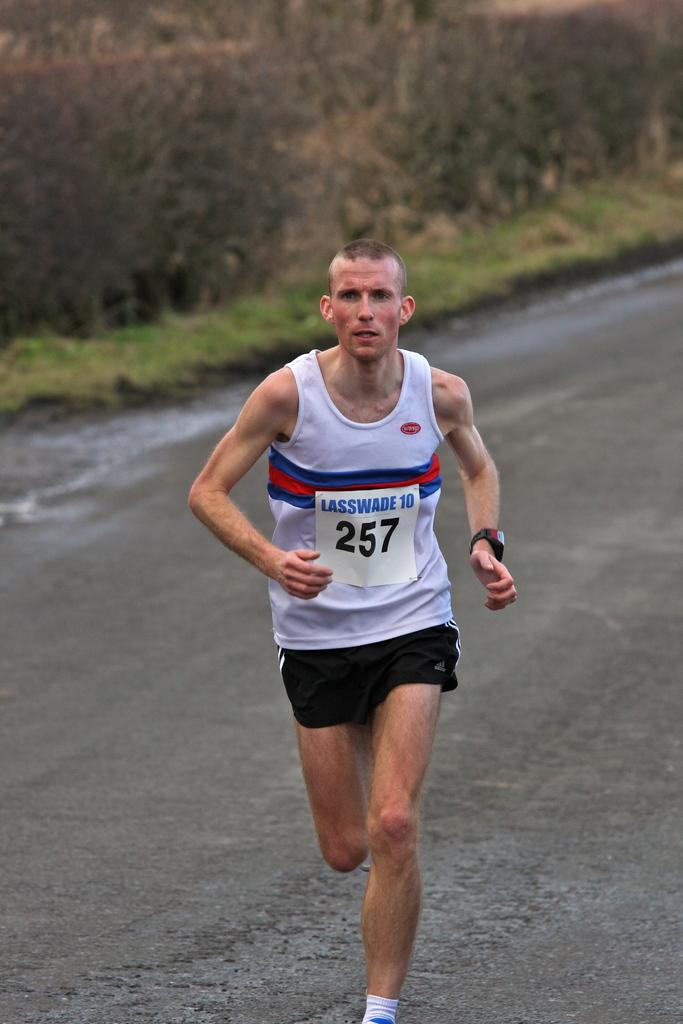<image>
Give a short and clear explanation of the subsequent image. A man running with a sign on his shirt with the numbers 257. 